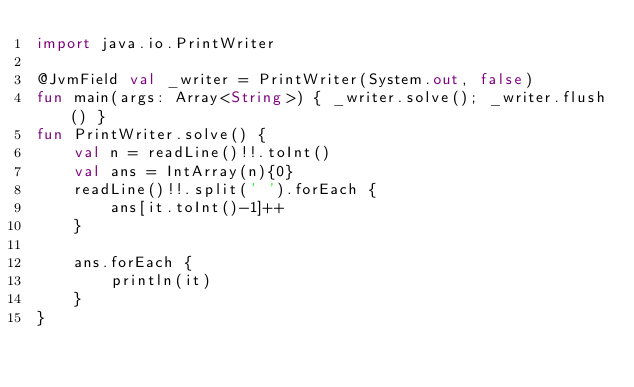Convert code to text. <code><loc_0><loc_0><loc_500><loc_500><_Kotlin_>import java.io.PrintWriter

@JvmField val _writer = PrintWriter(System.out, false)
fun main(args: Array<String>) { _writer.solve(); _writer.flush() }
fun PrintWriter.solve() {
    val n = readLine()!!.toInt()
    val ans = IntArray(n){0}
    readLine()!!.split(' ').forEach {
        ans[it.toInt()-1]++
    }

    ans.forEach {
        println(it)
    }
}
</code> 